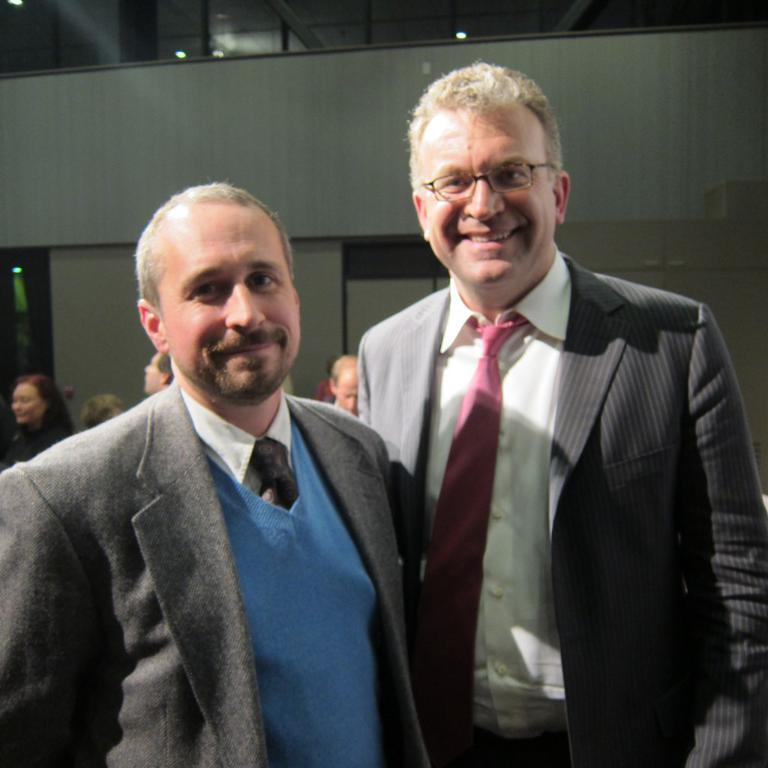What are the two people in the image wearing? The two people in the image are wearing suits. What can be seen on the ceiling in the image? Lights are attached to the ceiling in the image. Can you describe the people in the background of the image? There are people in the background of the image, but their specific appearance or actions are not discernible from the provided facts. What arithmetic problem is being solved by the people in the image? There is no indication in the image that the people are solving an arithmetic problem. --- Facts: 1. There is a car in the image. 2. The car is parked on the street. 3. There are trees in the background. 4. The sky is visible in the image. Absurd Topics: dance, ocean, sculpture Conversation: What is the main subject of the image? The main subject of the image is a car. Where is the car located in the image? The car is parked on the street in the image. What can be seen in the background of the image? There are trees in the background of the image. What else is visible in the image besides the car and trees? The sky is visible in the image. Reasoning: Let's think step by step in order to produce the conversation. We start by identifying the main subject of the image, which is the car. Then, we describe the car's location, which is parked on the street. Next, we mention the background elements, which include trees and the sky. Finally, we ensure that each question can be answered definitively with the information given and avoid yes/no questions. Absurd Question/Answer: Can you see any sculptures in the image? There is no sculpture present in the image. What type of dance is being performed in the background of the image? There is no dance or dancing activity depicted in the image. 